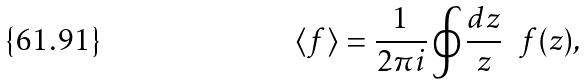Convert formula to latex. <formula><loc_0><loc_0><loc_500><loc_500>\langle f \rangle = \frac { 1 } { 2 \pi i } \oint \frac { d z } { z } \ \ f ( z ) ,</formula> 